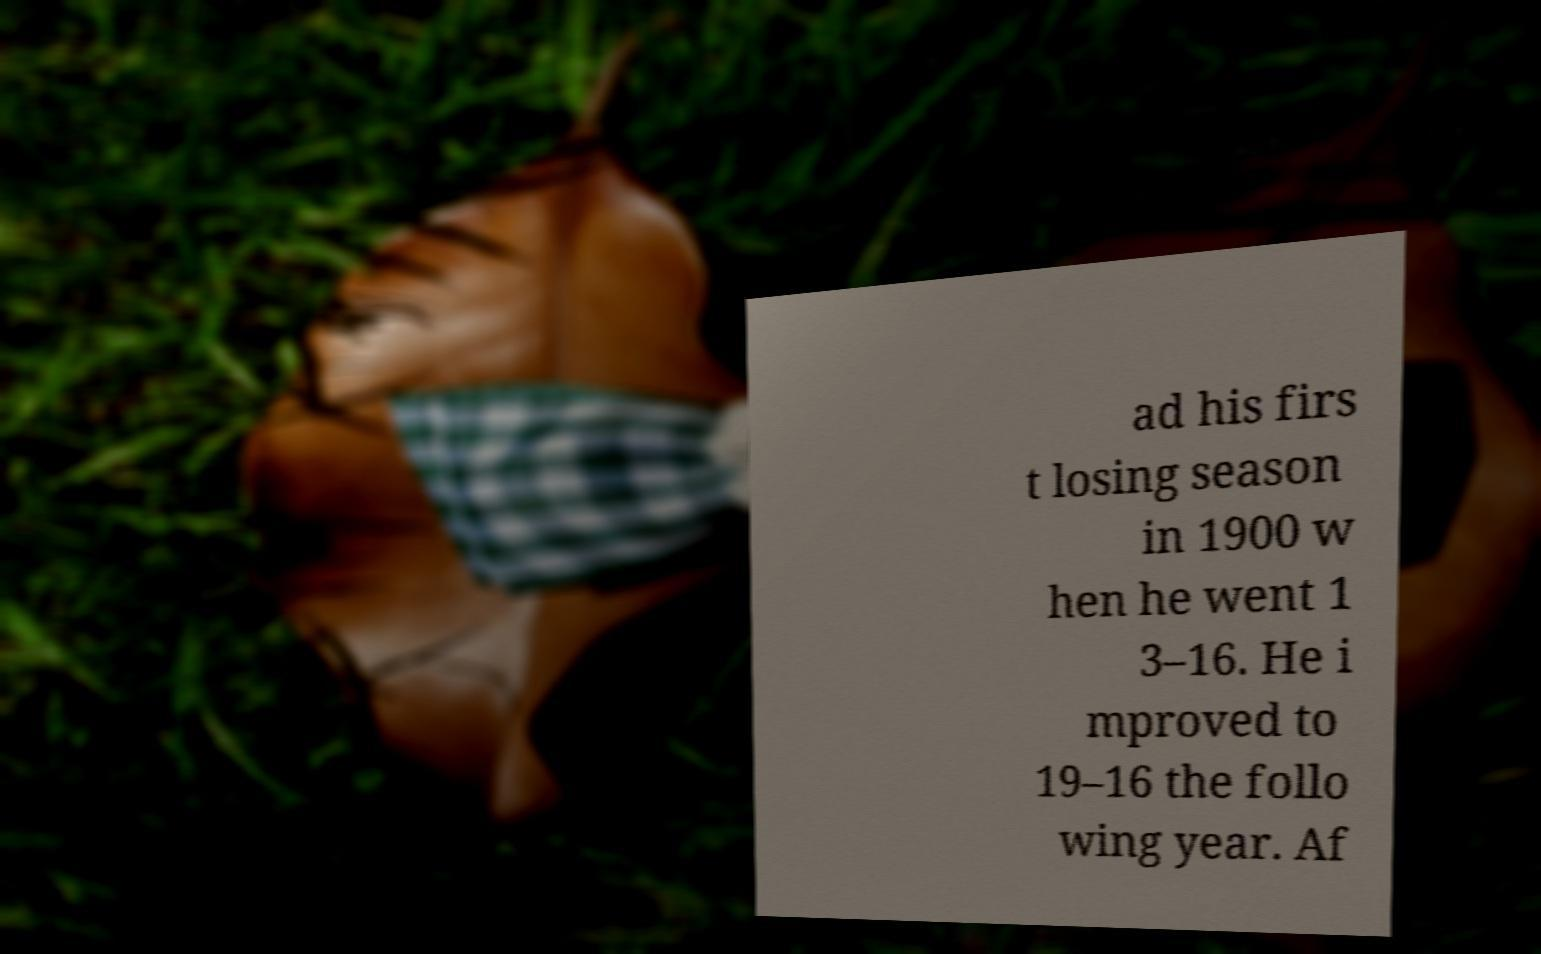Can you accurately transcribe the text from the provided image for me? ad his firs t losing season in 1900 w hen he went 1 3–16. He i mproved to 19–16 the follo wing year. Af 